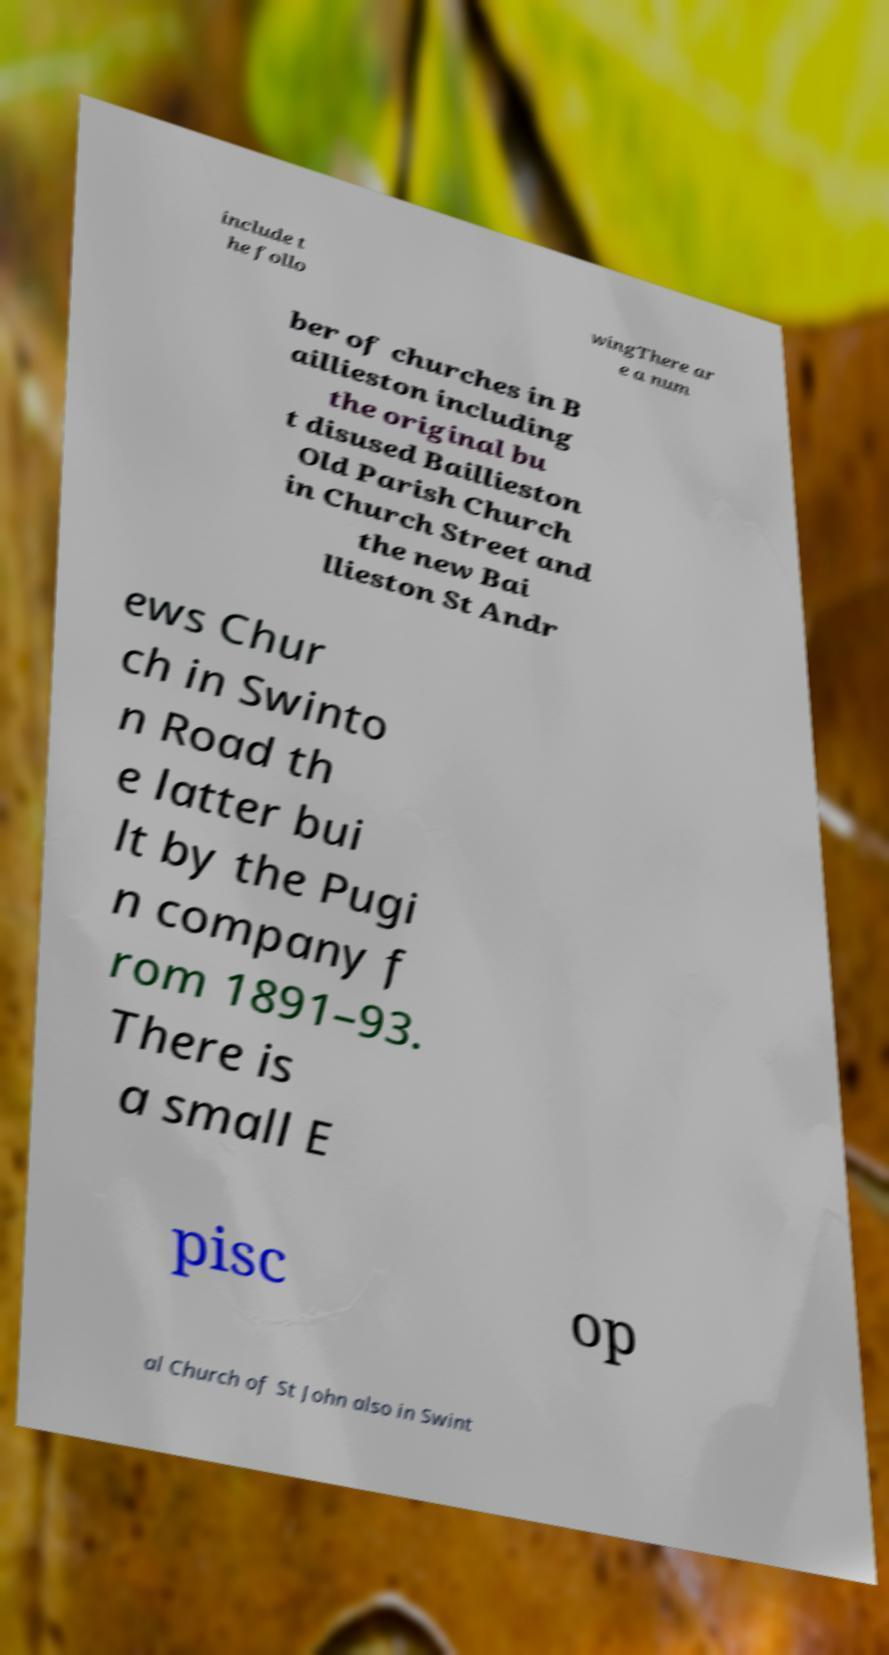What messages or text are displayed in this image? I need them in a readable, typed format. include t he follo wingThere ar e a num ber of churches in B aillieston including the original bu t disused Baillieston Old Parish Church in Church Street and the new Bai llieston St Andr ews Chur ch in Swinto n Road th e latter bui lt by the Pugi n company f rom 1891–93. There is a small E pisc op al Church of St John also in Swint 